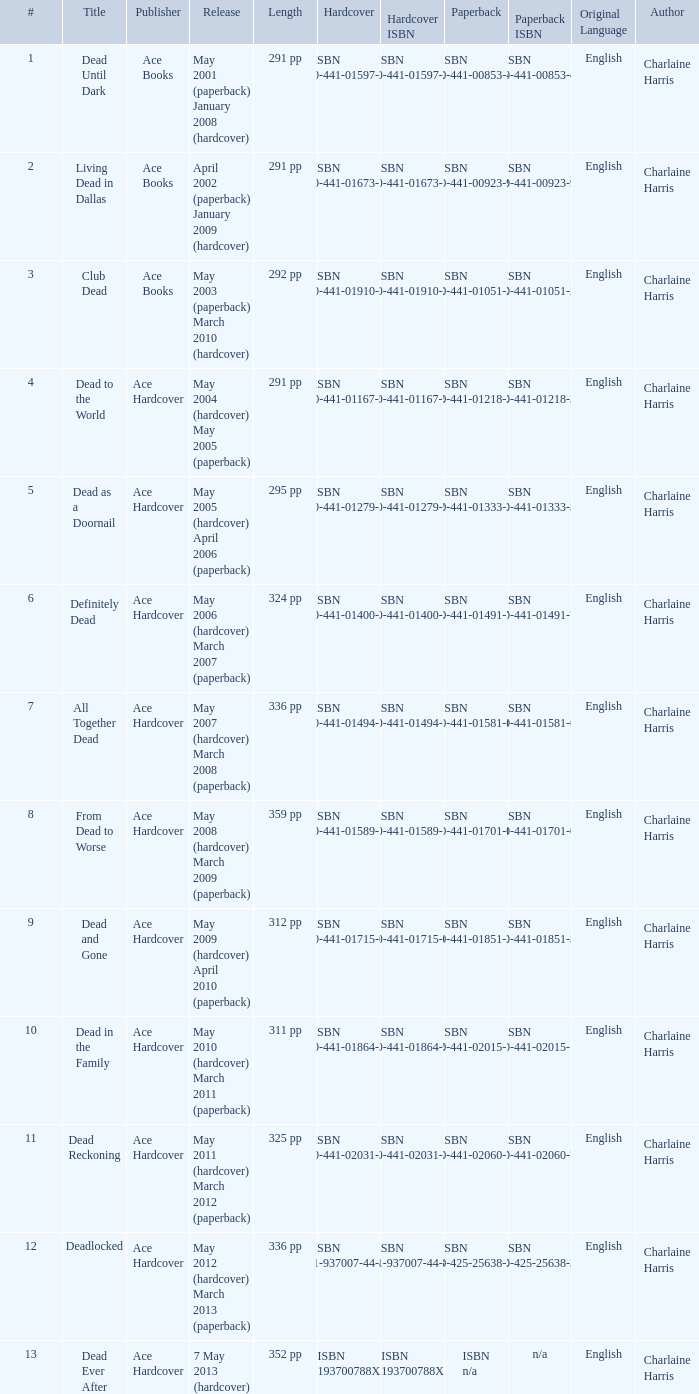Who pubilshed isbn 1-937007-44-8? Ace Hardcover. 